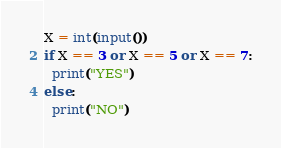<code> <loc_0><loc_0><loc_500><loc_500><_Python_>X = int(input())
if X == 3 or X == 5 or X == 7:
  print("YES")
else:
  print("NO")</code> 